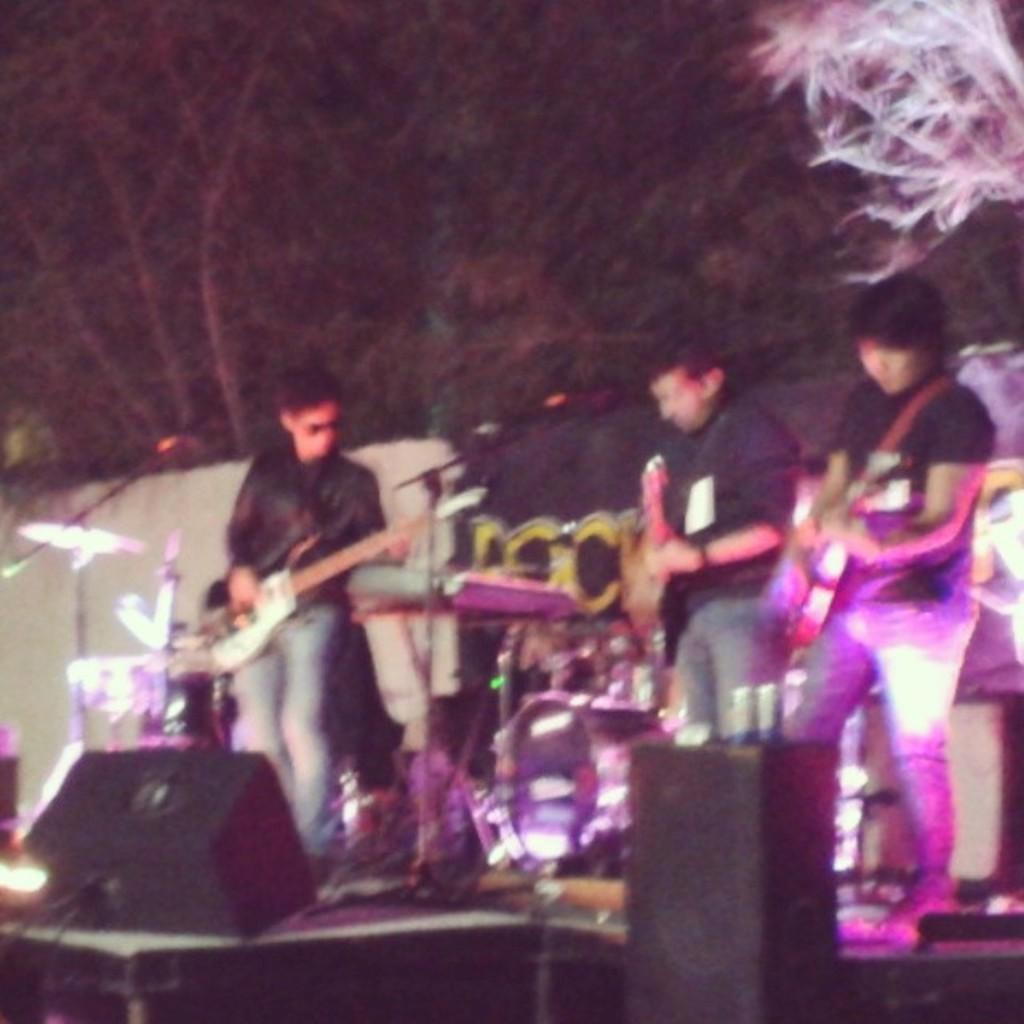Please provide a concise description of this image. In this image I can see three men are standing and I can see all of them are holding guitars. I can also see few mics, trees, a drum set and I can see this image is little bit blurry. 